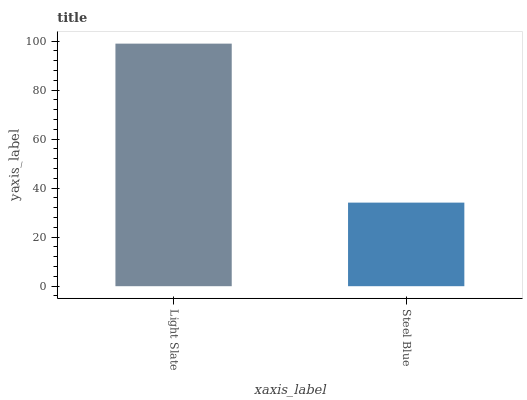Is Steel Blue the minimum?
Answer yes or no. Yes. Is Light Slate the maximum?
Answer yes or no. Yes. Is Steel Blue the maximum?
Answer yes or no. No. Is Light Slate greater than Steel Blue?
Answer yes or no. Yes. Is Steel Blue less than Light Slate?
Answer yes or no. Yes. Is Steel Blue greater than Light Slate?
Answer yes or no. No. Is Light Slate less than Steel Blue?
Answer yes or no. No. Is Light Slate the high median?
Answer yes or no. Yes. Is Steel Blue the low median?
Answer yes or no. Yes. Is Steel Blue the high median?
Answer yes or no. No. Is Light Slate the low median?
Answer yes or no. No. 